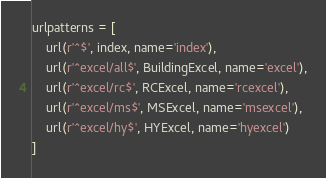<code> <loc_0><loc_0><loc_500><loc_500><_Python_>
urlpatterns = [
	url(r'^$', index, name='index'),
	url(r'^excel/all$', BuildingExcel, name='excel'),
	url(r'^excel/rc$', RCExcel, name='rcexcel'),
	url(r'^excel/ms$', MSExcel, name='msexcel'),
	url(r'^excel/hy$', HYExcel, name='hyexcel')
]</code> 